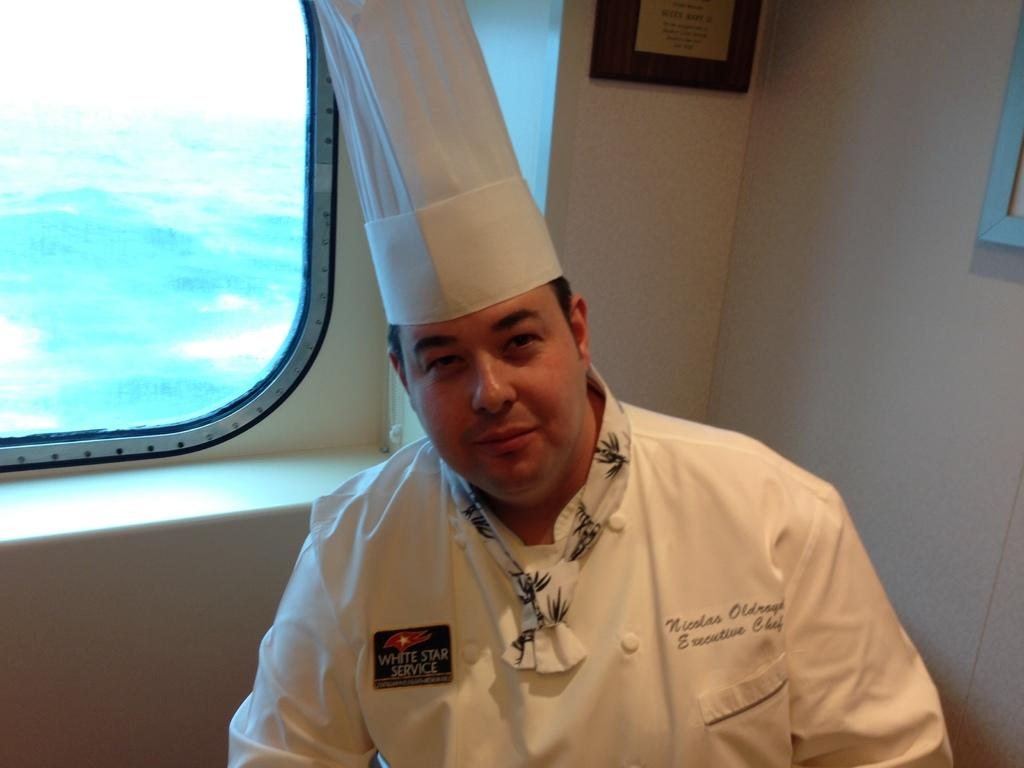Who is present in the image? There is a man in the image. What is the man doing in the image? The man is looking to his side. What is the man wearing in the image? The man is wearing a white dress and a cap on the left side. What can be seen in the background of the image? There is a glass window in the image. What type of jellyfish can be seen swimming near the man in the image? There are no jellyfish present in the image; it features a man wearing a white dress and a cap, looking to his side, with a glass window in the background. What time of day is it in the image, considering the presence of an umbrella? There is no mention of an umbrella in the image, and therefore we cannot determine the time of day based on its presence. 